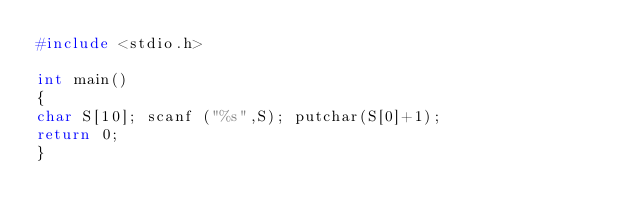Convert code to text. <code><loc_0><loc_0><loc_500><loc_500><_C++_>#include <stdio.h>

int main()
{
char S[10]; scanf ("%s",S); putchar(S[0]+1);
return 0;
}</code> 